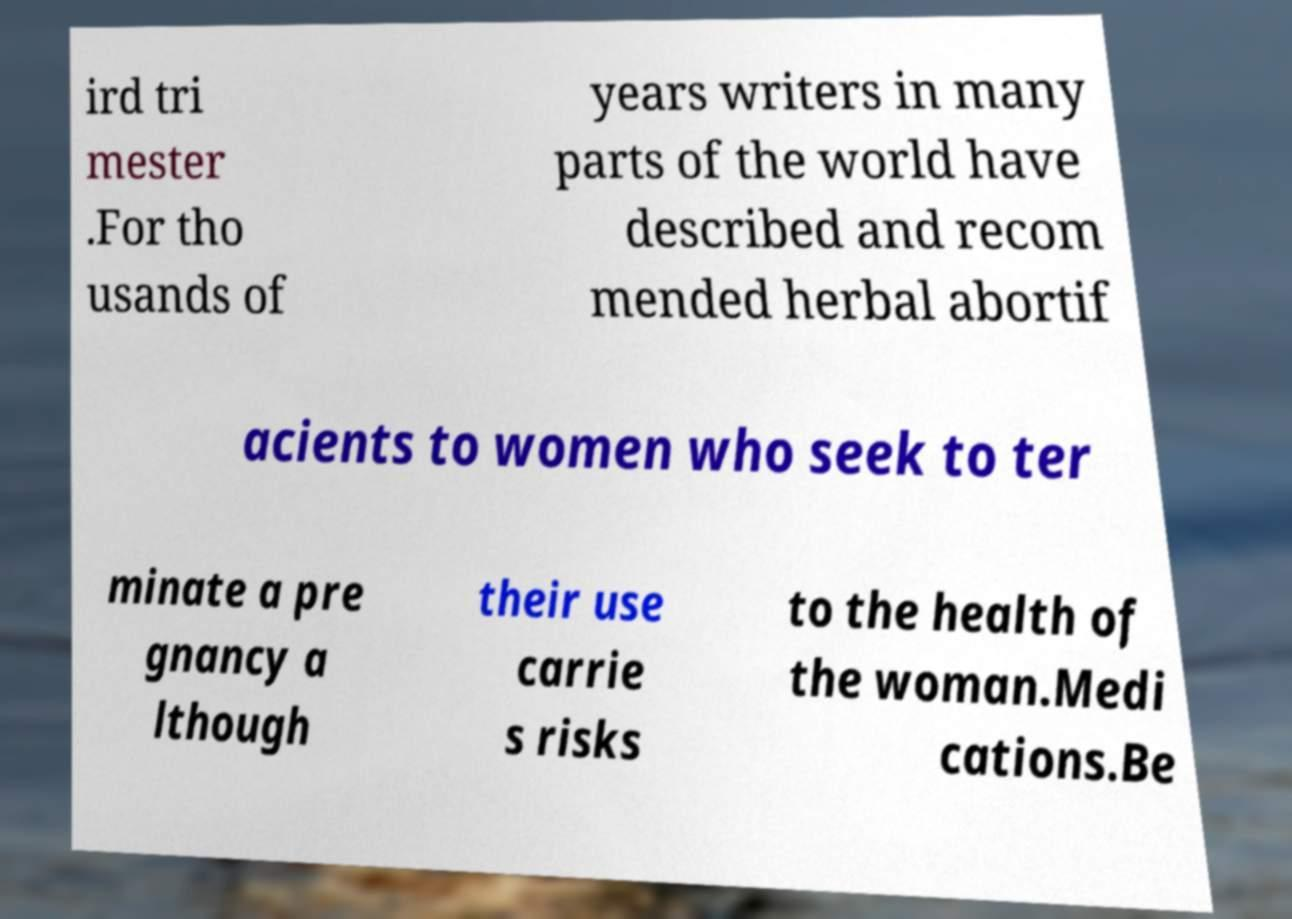Can you accurately transcribe the text from the provided image for me? ird tri mester .For tho usands of years writers in many parts of the world have described and recom mended herbal abortif acients to women who seek to ter minate a pre gnancy a lthough their use carrie s risks to the health of the woman.Medi cations.Be 